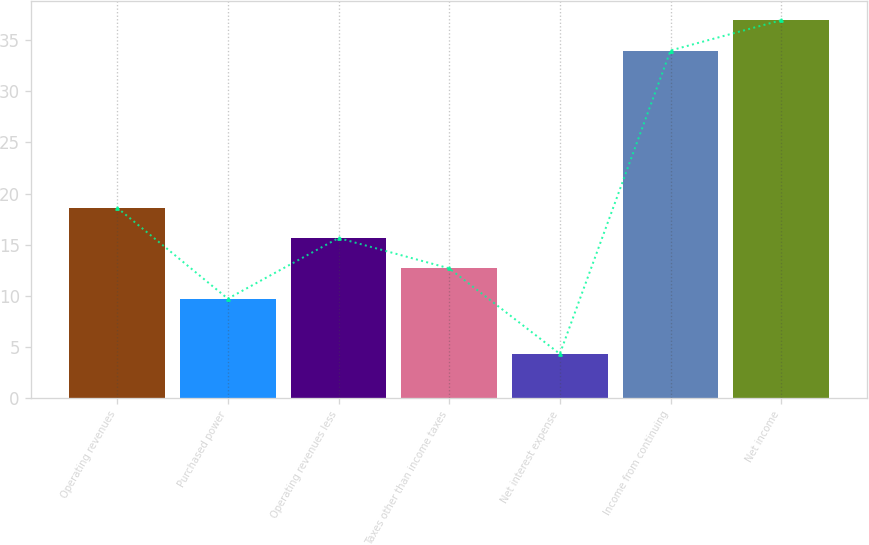Convert chart to OTSL. <chart><loc_0><loc_0><loc_500><loc_500><bar_chart><fcel>Operating revenues<fcel>Purchased power<fcel>Operating revenues less<fcel>Taxes other than income taxes<fcel>Net interest expense<fcel>Income from continuing<fcel>Net income<nl><fcel>18.61<fcel>9.7<fcel>15.64<fcel>12.67<fcel>4.3<fcel>34<fcel>36.97<nl></chart> 